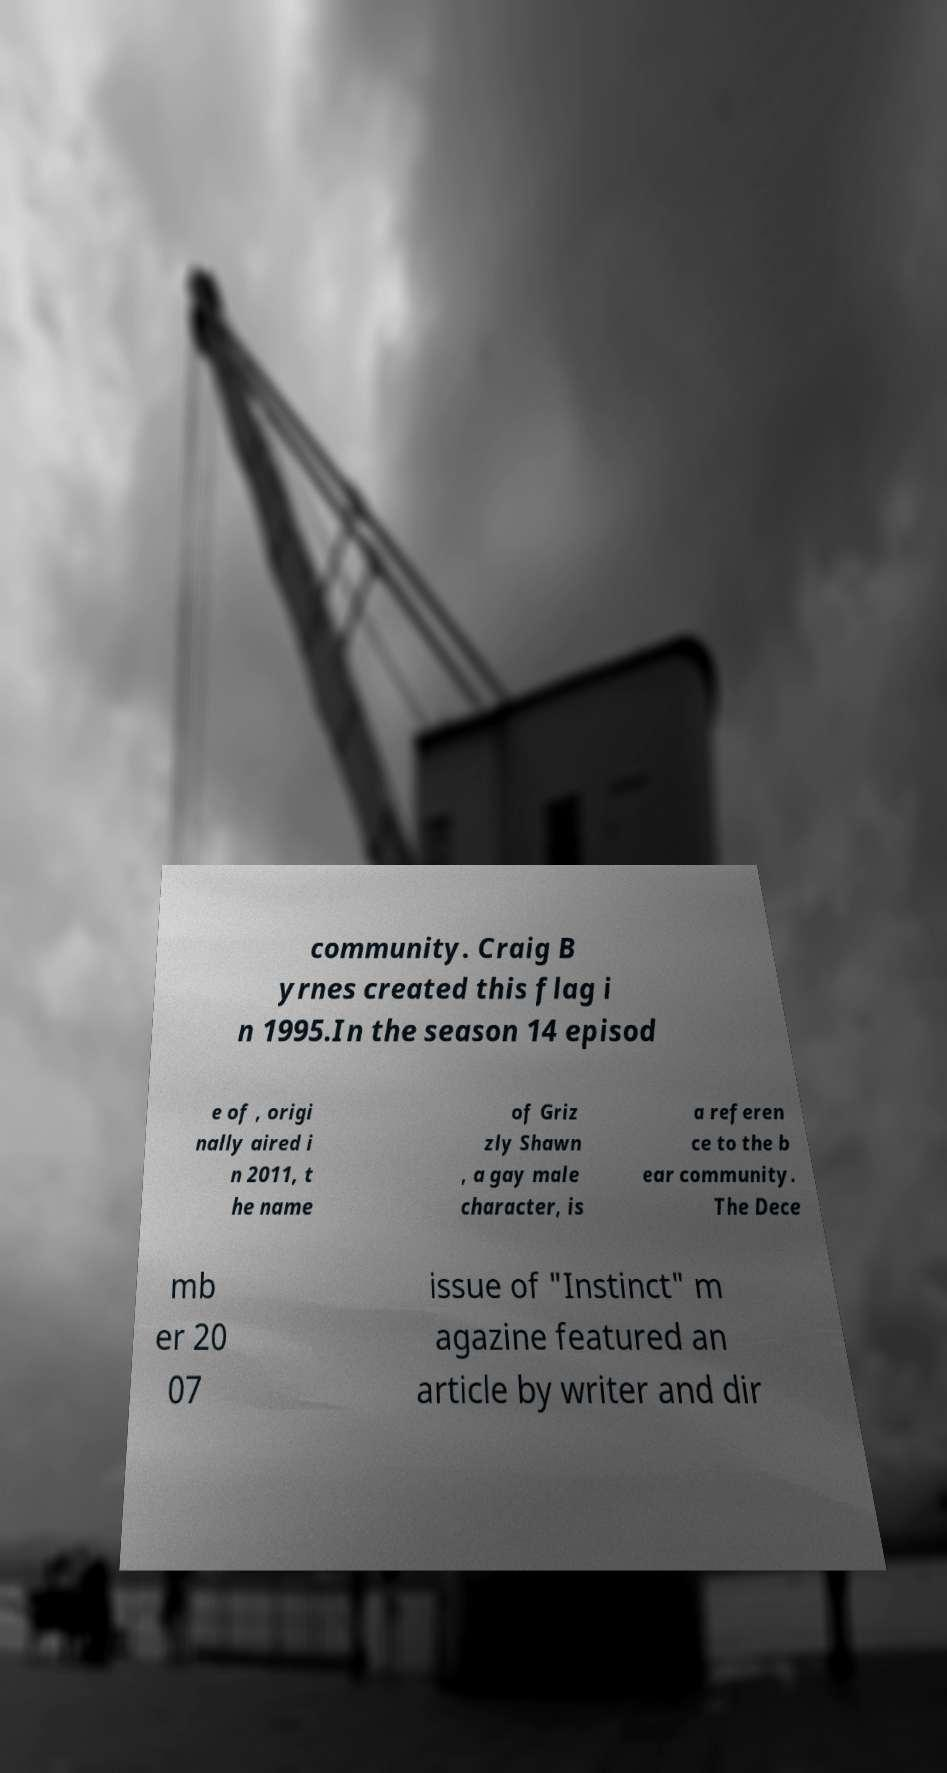Could you extract and type out the text from this image? community. Craig B yrnes created this flag i n 1995.In the season 14 episod e of , origi nally aired i n 2011, t he name of Griz zly Shawn , a gay male character, is a referen ce to the b ear community. The Dece mb er 20 07 issue of "Instinct" m agazine featured an article by writer and dir 